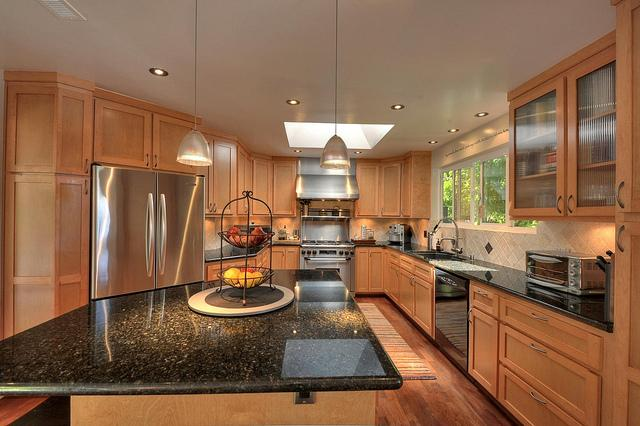What is the countertop in the middle called?

Choices:
A) bar
B) cart
C) island
D) kitchen table island 